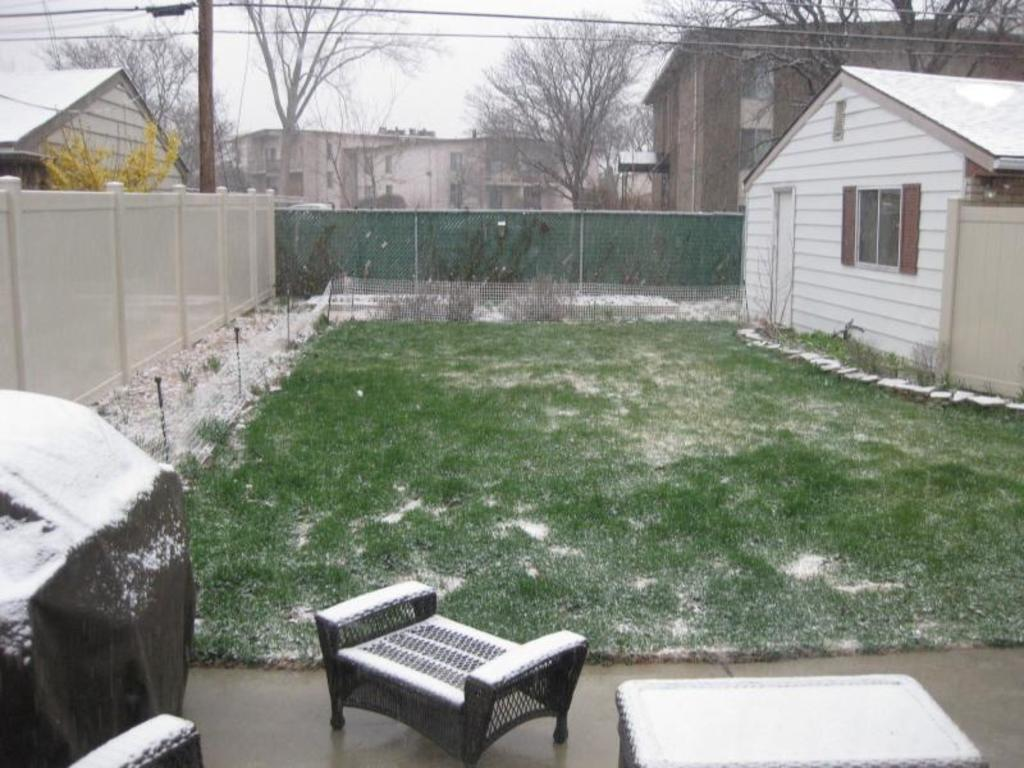What type of structures can be seen in the image? There are buildings in the image. What type of vegetation is present in the image? There are trees in the image. What covers the ground in the image? There is grass on the ground in the image. What weather condition is depicted in the image? There is snow visible in the image. What type of furniture is present in the image? There is a chair and a table in the image. Where is the bedroom located in the image? There is no bedroom present in the image. How many steps are required to reach the chair from the table in the image? There is no information about steps or distances between objects in the image. 